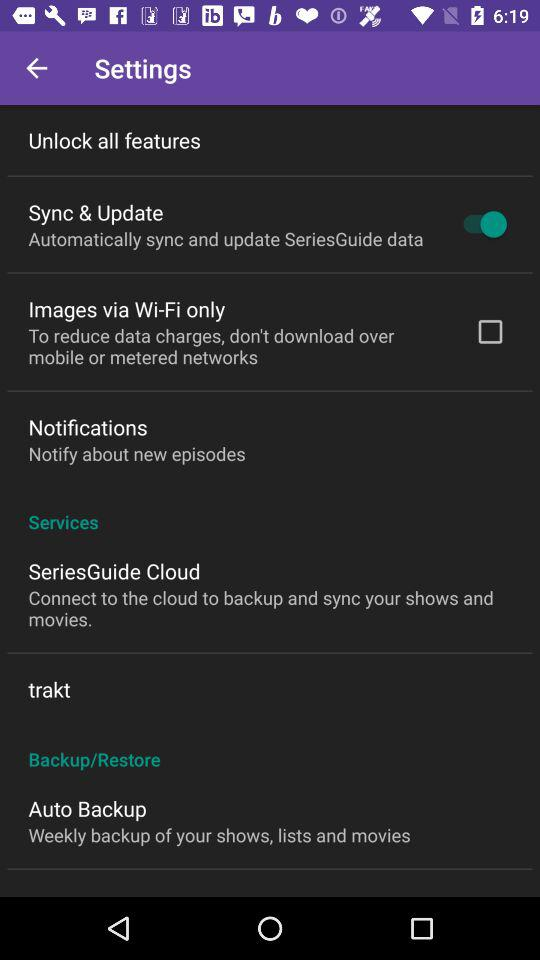What is the status of the sync and update? The sync and update feature for the SeriesGuide app is currently enabled, as indicated by the toggle switch being in the 'on' position. 